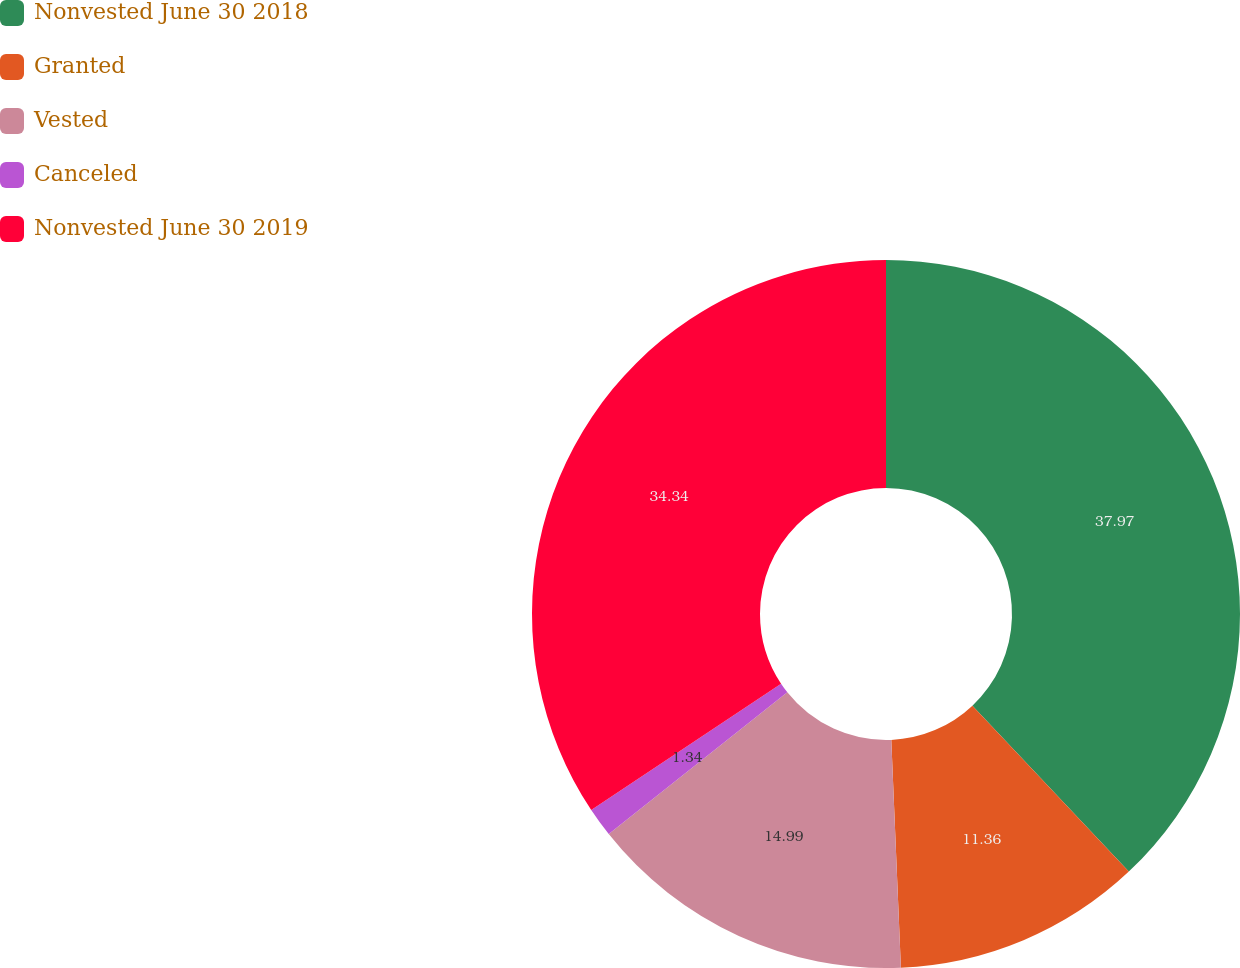Convert chart. <chart><loc_0><loc_0><loc_500><loc_500><pie_chart><fcel>Nonvested June 30 2018<fcel>Granted<fcel>Vested<fcel>Canceled<fcel>Nonvested June 30 2019<nl><fcel>37.97%<fcel>11.36%<fcel>14.99%<fcel>1.34%<fcel>34.34%<nl></chart> 